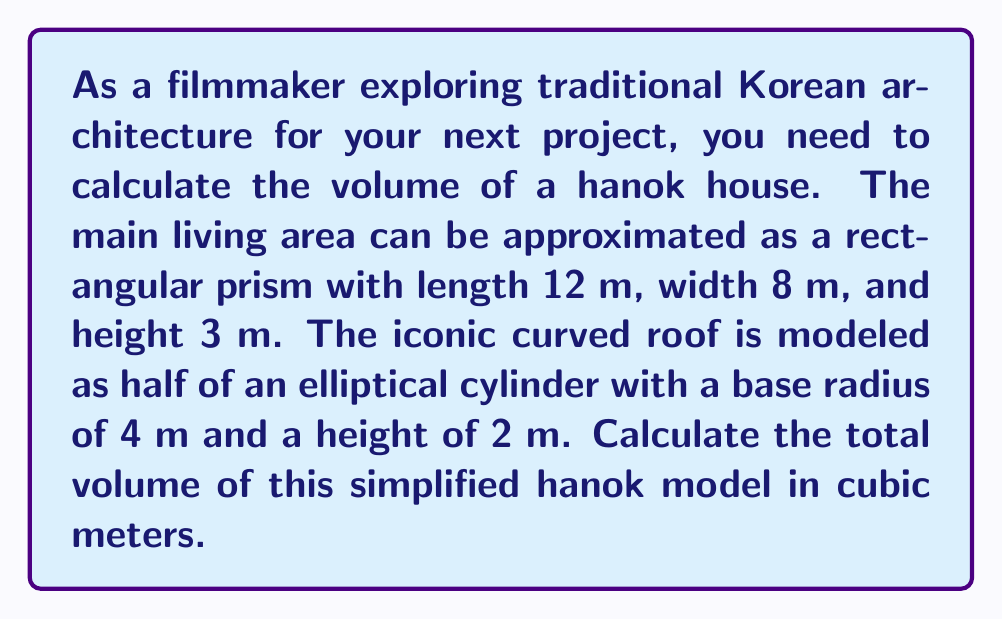What is the answer to this math problem? To solve this problem, we need to calculate the volumes of two geometric shapes and add them together:

1. Volume of the rectangular prism (main living area):
   $$V_{prism} = l \times w \times h$$
   $$V_{prism} = 12 \text{ m} \times 8 \text{ m} \times 3 \text{ m} = 288 \text{ m}^3$$

2. Volume of half an elliptical cylinder (curved roof):
   The volume of a full elliptical cylinder is given by:
   $$V_{cylinder} = \pi a b h$$
   where $a$ and $b$ are the semi-major and semi-minor axes, and $h$ is the height.
   
   In this case, $a = 4 \text{ m}$, $b = 4 \text{ m}$ (circular base), and $h = 12 \text{ m}$ (length of the house).
   
   $$V_{full cylinder} = \pi \times 4 \text{ m} \times 4 \text{ m} \times 12 \text{ m} = 192\pi \text{ m}^3$$
   
   Since we only need half of this volume:
   $$V_{roof} = \frac{1}{2} \times 192\pi \text{ m}^3 = 96\pi \text{ m}^3$$

3. Total volume:
   $$V_{total} = V_{prism} + V_{roof}$$
   $$V_{total} = 288 \text{ m}^3 + 96\pi \text{ m}^3$$
   $$V_{total} = 288 + 301.59 = 589.59 \text{ m}^3$$

[asy]
import three;

size(200);
currentprojection=perspective(6,3,2);

// Main living area
draw((0,0,0)--(12,0,0)--(12,8,0)--(0,8,0)--cycle);
draw((0,0,3)--(12,0,3)--(12,8,3)--(0,8,3)--cycle);
draw((0,0,0)--(0,0,3));
draw((12,0,0)--(12,0,3));
draw((12,8,0)--(12,8,3));
draw((0,8,0)--(0,8,3));

// Roof
path3 p=arc((6,4,3),(10,4,3),(6,8,3));
draw(p);
draw(shift(0,0,12)*p);
draw((6,4,3)--(6,4,15));
draw((6,8,3)--(6,8,15));

// Labels
label("12 m", (6,0,0), S);
label("8 m", (12,4,0), E);
label("3 m", (12,8,1.5), E);
label("4 m", (6,6,3), N);
label("2 m", (10,4,3), NE);
[/asy]
Answer: 589.59 m³ 